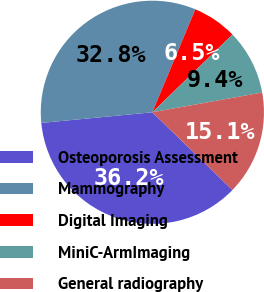Convert chart to OTSL. <chart><loc_0><loc_0><loc_500><loc_500><pie_chart><fcel>Osteoporosis Assessment<fcel>Mammography<fcel>Digital Imaging<fcel>MiniC-ArmImaging<fcel>General radiography<nl><fcel>36.21%<fcel>32.81%<fcel>6.45%<fcel>9.42%<fcel>15.1%<nl></chart> 